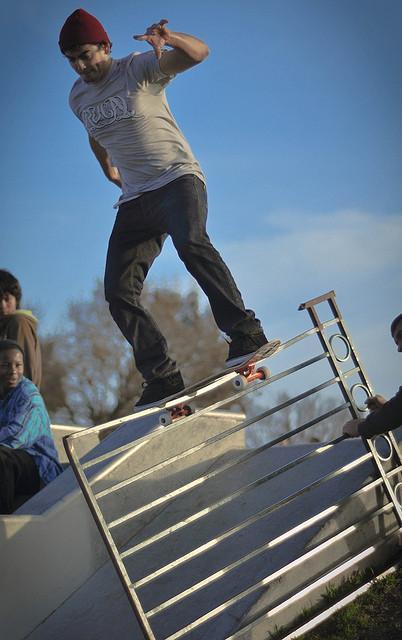Why is the man on top of the railing?
Indicate the correct response and explain using: 'Answer: answer
Rationale: rationale.'
Options: To wax, to grind, to flip, to clean. Answer: to grind.
Rationale: He is doing a stunt. 